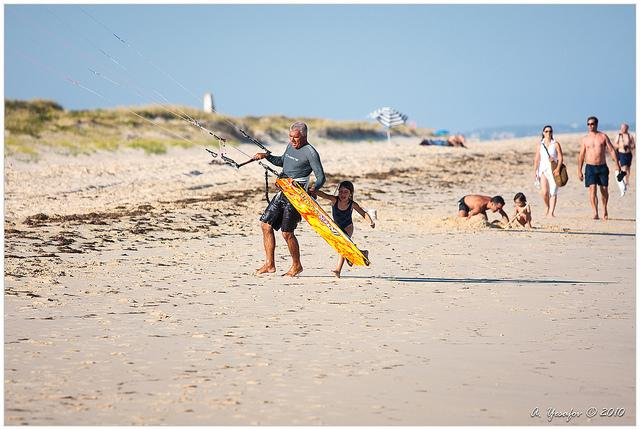What is the man helping the young woman with in the sand? kite 